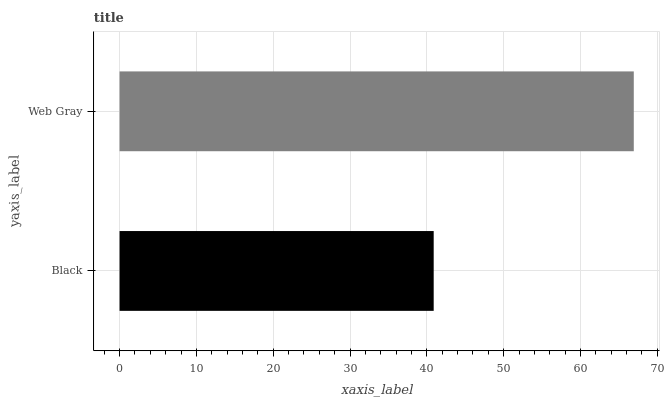Is Black the minimum?
Answer yes or no. Yes. Is Web Gray the maximum?
Answer yes or no. Yes. Is Web Gray the minimum?
Answer yes or no. No. Is Web Gray greater than Black?
Answer yes or no. Yes. Is Black less than Web Gray?
Answer yes or no. Yes. Is Black greater than Web Gray?
Answer yes or no. No. Is Web Gray less than Black?
Answer yes or no. No. Is Web Gray the high median?
Answer yes or no. Yes. Is Black the low median?
Answer yes or no. Yes. Is Black the high median?
Answer yes or no. No. Is Web Gray the low median?
Answer yes or no. No. 